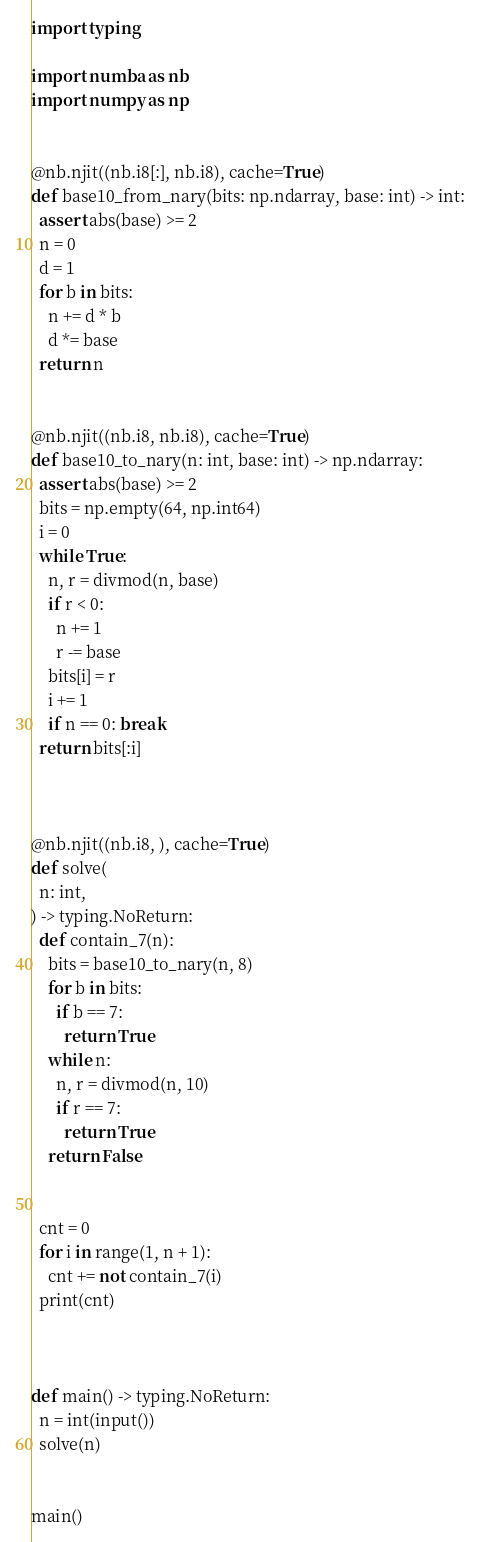Convert code to text. <code><loc_0><loc_0><loc_500><loc_500><_Python_>import typing

import numba as nb
import numpy as np


@nb.njit((nb.i8[:], nb.i8), cache=True)
def base10_from_nary(bits: np.ndarray, base: int) -> int:
  assert abs(base) >= 2
  n = 0
  d = 1
  for b in bits:
    n += d * b
    d *= base
  return n


@nb.njit((nb.i8, nb.i8), cache=True)
def base10_to_nary(n: int, base: int) -> np.ndarray:
  assert abs(base) >= 2
  bits = np.empty(64, np.int64)
  i = 0
  while True:
    n, r = divmod(n, base)
    if r < 0:
      n += 1
      r -= base
    bits[i] = r
    i += 1
    if n == 0: break
  return bits[:i]



@nb.njit((nb.i8, ), cache=True)
def solve(
  n: int,
) -> typing.NoReturn:
  def contain_7(n):
    bits = base10_to_nary(n, 8)
    for b in bits:
      if b == 7:
        return True
    while n:
      n, r = divmod(n, 10)
      if r == 7:
        return True
    return False


  cnt = 0
  for i in range(1, n + 1):
    cnt += not contain_7(i)
  print(cnt)



def main() -> typing.NoReturn:
  n = int(input())
  solve(n)


main()
</code> 